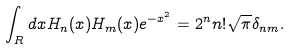<formula> <loc_0><loc_0><loc_500><loc_500>\int _ { R } d x H _ { n } ( x ) H _ { m } ( x ) e ^ { - x ^ { 2 } } = 2 ^ { n } n ! \sqrt { \pi } \delta _ { n m } .</formula> 